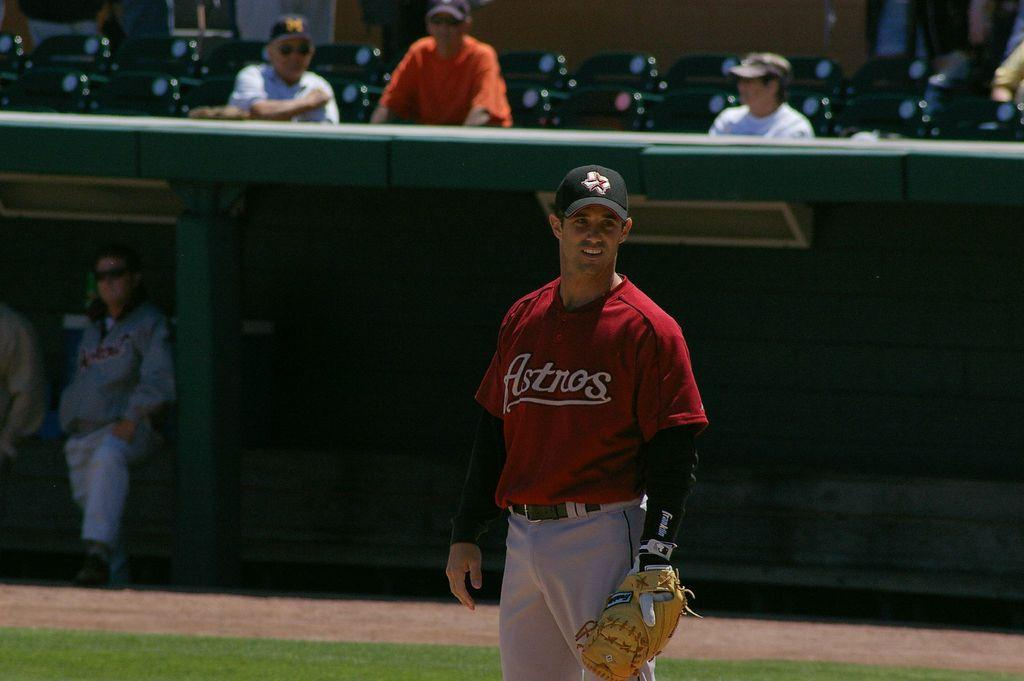<image>
Present a compact description of the photo's key features. A baseball player for the Astros is standing on the field. 